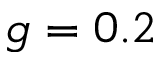<formula> <loc_0><loc_0><loc_500><loc_500>g = 0 . 2</formula> 